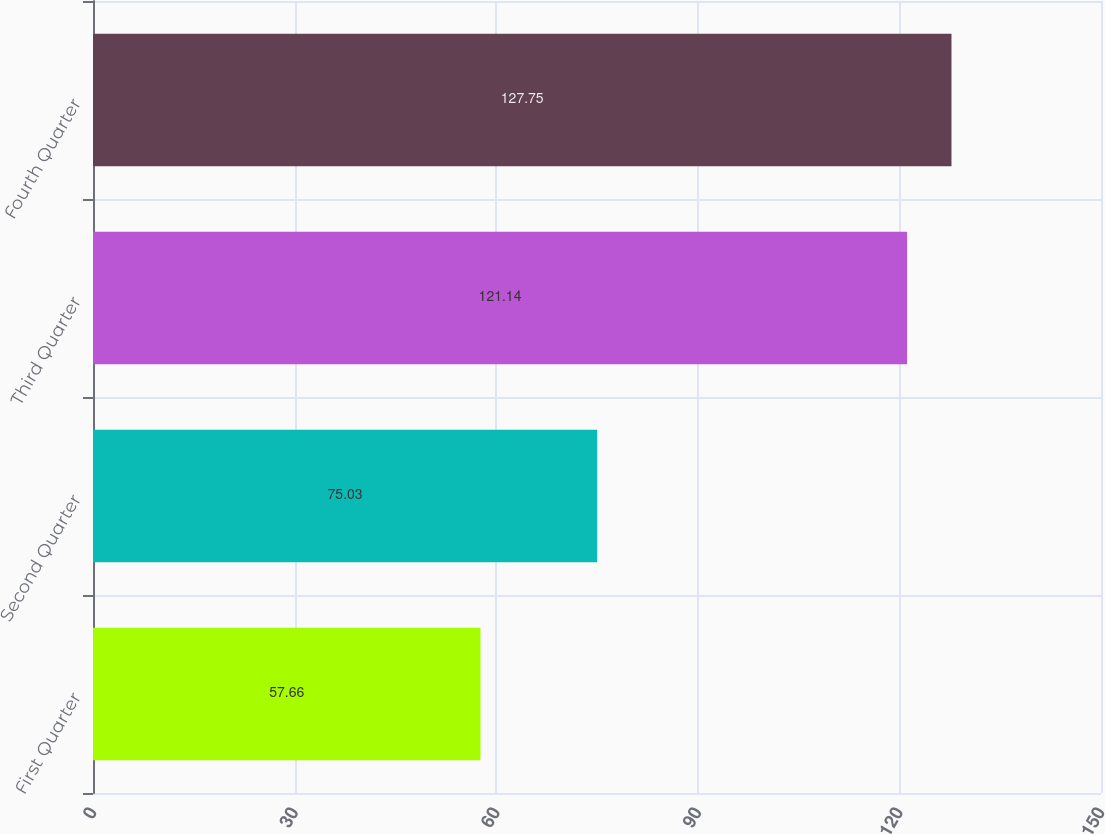Convert chart to OTSL. <chart><loc_0><loc_0><loc_500><loc_500><bar_chart><fcel>First Quarter<fcel>Second Quarter<fcel>Third Quarter<fcel>Fourth Quarter<nl><fcel>57.66<fcel>75.03<fcel>121.14<fcel>127.75<nl></chart> 